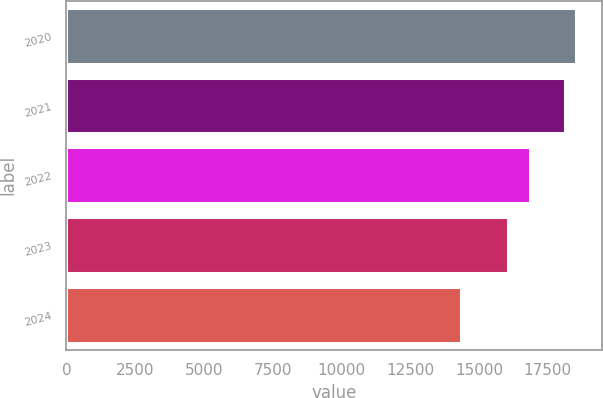Convert chart to OTSL. <chart><loc_0><loc_0><loc_500><loc_500><bar_chart><fcel>2020<fcel>2021<fcel>2022<fcel>2023<fcel>2024<nl><fcel>18534.1<fcel>18137<fcel>16844<fcel>16047<fcel>14360<nl></chart> 